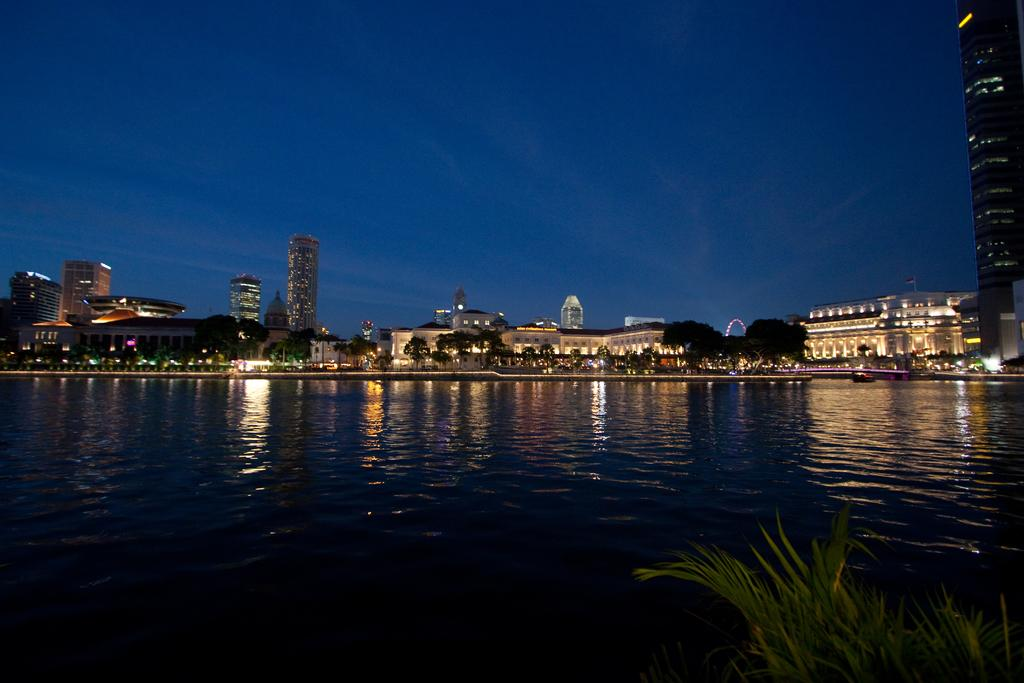What type of structures can be seen in the image? There are buildings in the image. What other natural elements are present in the image? There are trees in the image. Are there any artificial light sources visible in the image? Yes, there are lights in the image. What type of body of water can be seen in the image? There is water visible in the image. What is the color of the sky in the image? The sky is blue in color. Can you hear any noise coming from the buildings in the image? The image is silent, and there is no indication of any noise. How many feet are visible in the image? There are no feet present in the image. 